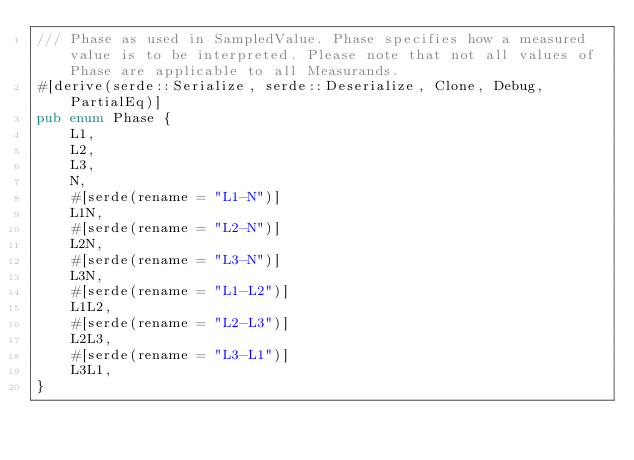<code> <loc_0><loc_0><loc_500><loc_500><_Rust_>/// Phase as used in SampledValue. Phase specifies how a measured value is to be interpreted. Please note that not all values of Phase are applicable to all Measurands.
#[derive(serde::Serialize, serde::Deserialize, Clone, Debug, PartialEq)]
pub enum Phase {
    L1,
    L2,
    L3,
    N,
    #[serde(rename = "L1-N")]
    L1N,
    #[serde(rename = "L2-N")]
    L2N,
    #[serde(rename = "L3-N")]
    L3N,
    #[serde(rename = "L1-L2")]
    L1L2,
    #[serde(rename = "L2-L3")]
    L2L3,
    #[serde(rename = "L3-L1")]
    L3L1,
}
</code> 